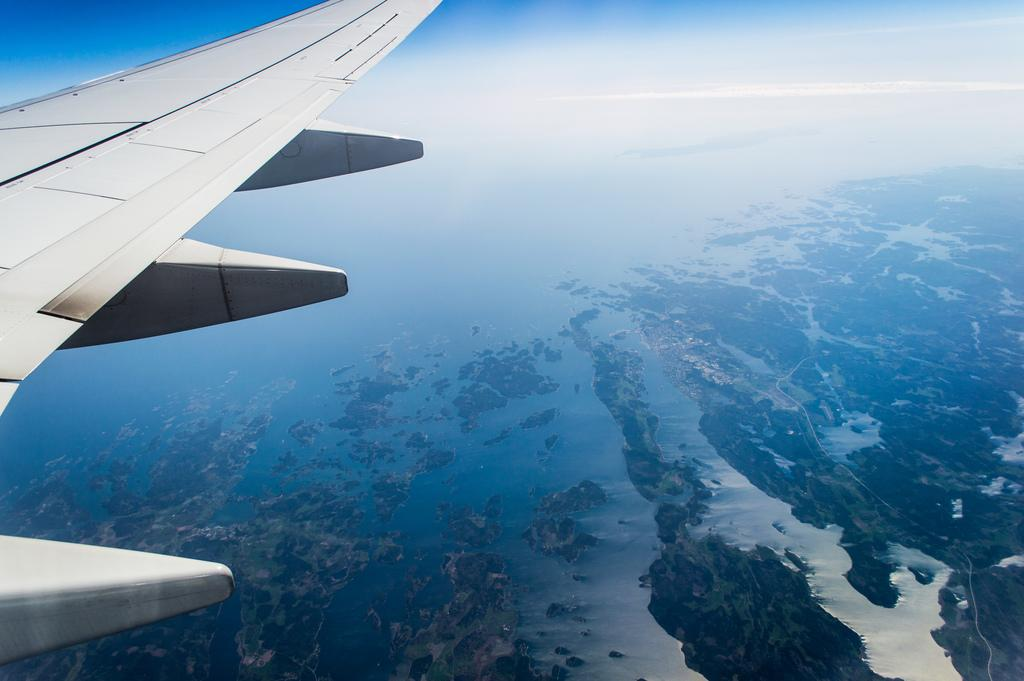What can be seen at the top of the image? The sky is visible in the image. What part of an airplane is present on the left side of the image? There is an airplane's wing on the left side of the image. How many mice are sitting in a line on the airplane's wing in the image? There are no mice present in the image, and therefore no such activity can be observed. 